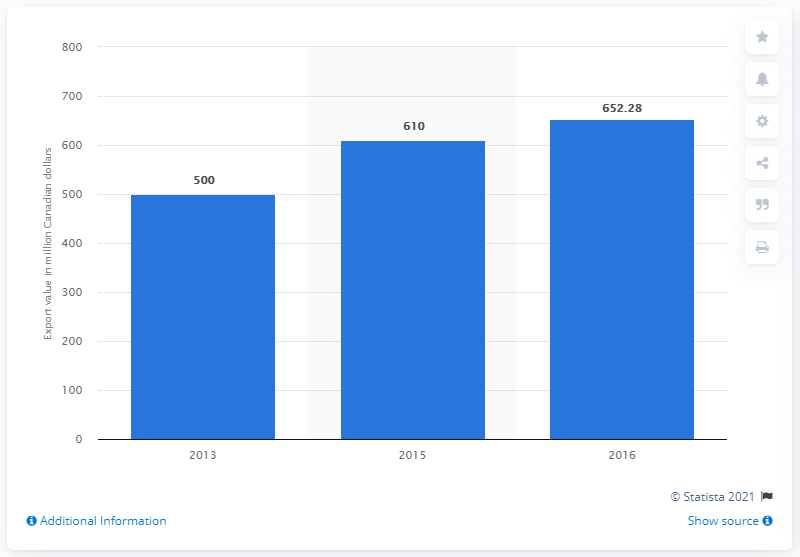Specify some key components in this picture. In 2016, the value of Canadian organic exports was CAD 652.28 million. In 2015, the value of Canadian organic exports was 610 million Canadian dollars. 